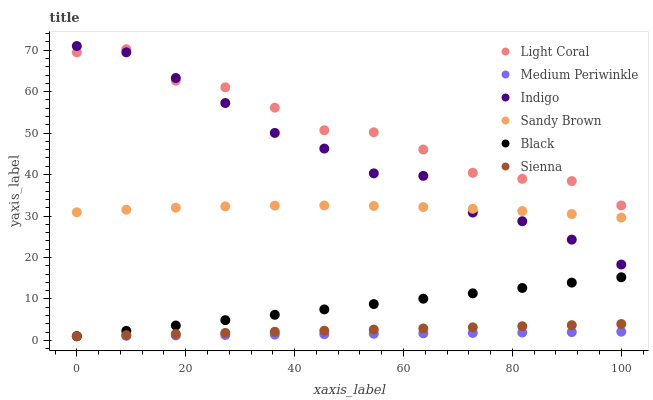Does Medium Periwinkle have the minimum area under the curve?
Answer yes or no. Yes. Does Light Coral have the maximum area under the curve?
Answer yes or no. Yes. Does Indigo have the minimum area under the curve?
Answer yes or no. No. Does Indigo have the maximum area under the curve?
Answer yes or no. No. Is Sienna the smoothest?
Answer yes or no. Yes. Is Light Coral the roughest?
Answer yes or no. Yes. Is Indigo the smoothest?
Answer yes or no. No. Is Indigo the roughest?
Answer yes or no. No. Does Sienna have the lowest value?
Answer yes or no. Yes. Does Indigo have the lowest value?
Answer yes or no. No. Does Indigo have the highest value?
Answer yes or no. Yes. Does Medium Periwinkle have the highest value?
Answer yes or no. No. Is Black less than Sandy Brown?
Answer yes or no. Yes. Is Light Coral greater than Medium Periwinkle?
Answer yes or no. Yes. Does Medium Periwinkle intersect Sienna?
Answer yes or no. Yes. Is Medium Periwinkle less than Sienna?
Answer yes or no. No. Is Medium Periwinkle greater than Sienna?
Answer yes or no. No. Does Black intersect Sandy Brown?
Answer yes or no. No. 